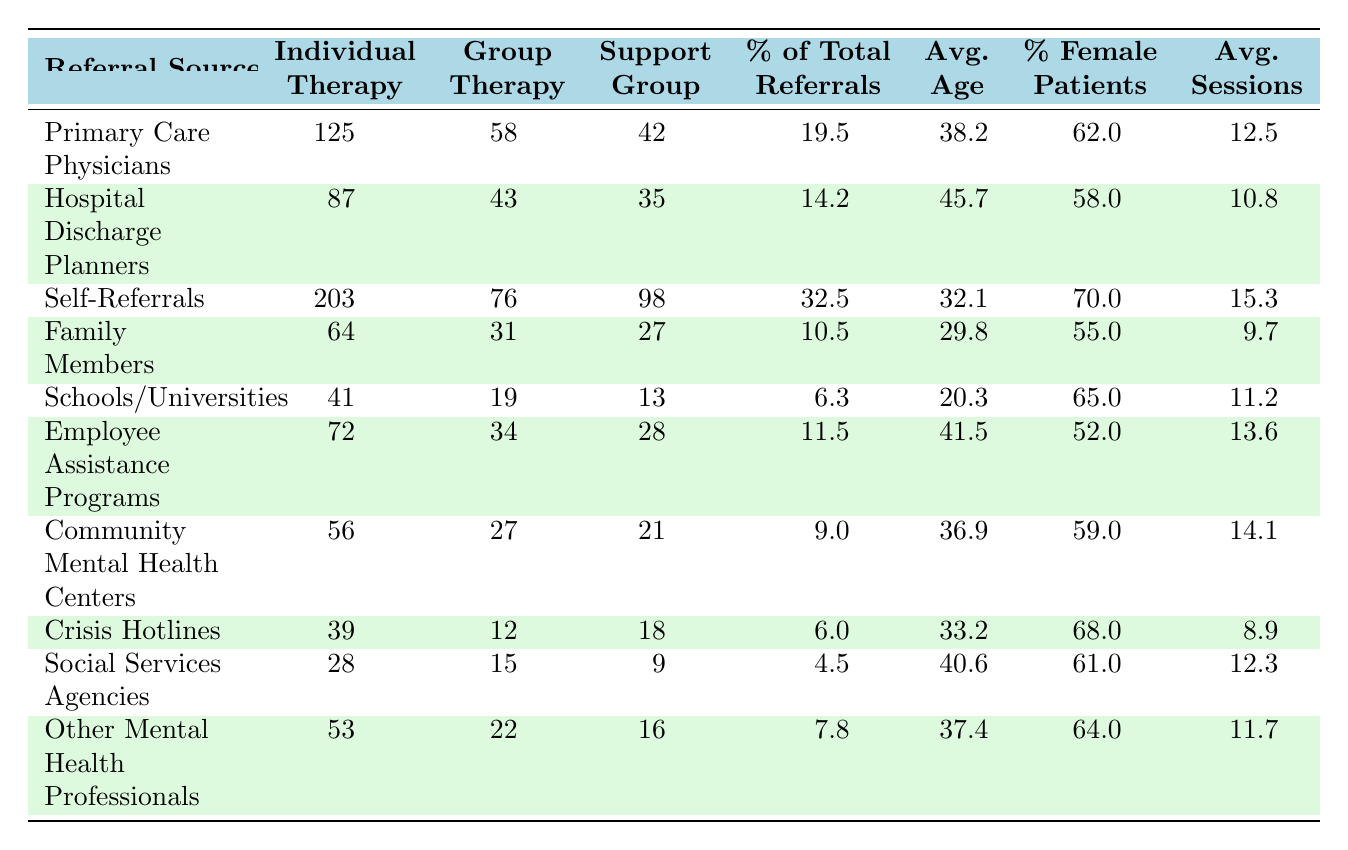What is the highest referral source for individual therapy? The table shows that Self-Referrals have the highest count for individual therapy at 203 referrals.
Answer: Self-Referrals Which referral source had the lowest number of group therapy referrals? The lowest number of group therapy referrals is from Crisis Hotlines, with 12 referrals.
Answer: Crisis Hotlines What percentage of total referrals does Family Members represent? According to the table, Family Members account for 10.5% of total referrals.
Answer: 10.5% What is the average patient age for referrals coming from Community Mental Health Centers? The table lists the average patient age for Community Mental Health Centers as 36.9 years.
Answer: 36.9 How many total referrals for support groups does Employee Assistance Programs provide? Employee Assistance Programs refers 28 individuals to support groups.
Answer: 28 Which referral source has the highest percentage of female patients? The Self-Referrals source has the highest percentage of female patients at 70%.
Answer: 70% What is the average number of sessions attended by patients referred by Primary Care Physicians? Patients referred by Primary Care Physicians attend an average of 12.5 sessions as per the table.
Answer: 12.5 If we combine the individual therapy and support group referrals from Schools/Universities, what is the total? The individual therapy referrals from Schools/Universities is 41 and support group referrals is 13. Adding these yields 41 + 13 = 54 total referrals.
Answer: 54 Is the average patient age higher for Hospital Discharge Planners than for Self-Referrals? The average patient age for Hospital Discharge Planners is 45.7, while for Self-Referrals it is 32.1. Thus, it is higher for Hospital Discharge Planners.
Answer: Yes What is the difference in the percentage of total referrals between Primary Care Physicians and Other Mental Health Professionals? Primary Care Physicians have 19.5% while Other Mental Health Professionals have 7.8%. The difference is 19.5 - 7.8 = 11.7%.
Answer: 11.7% 